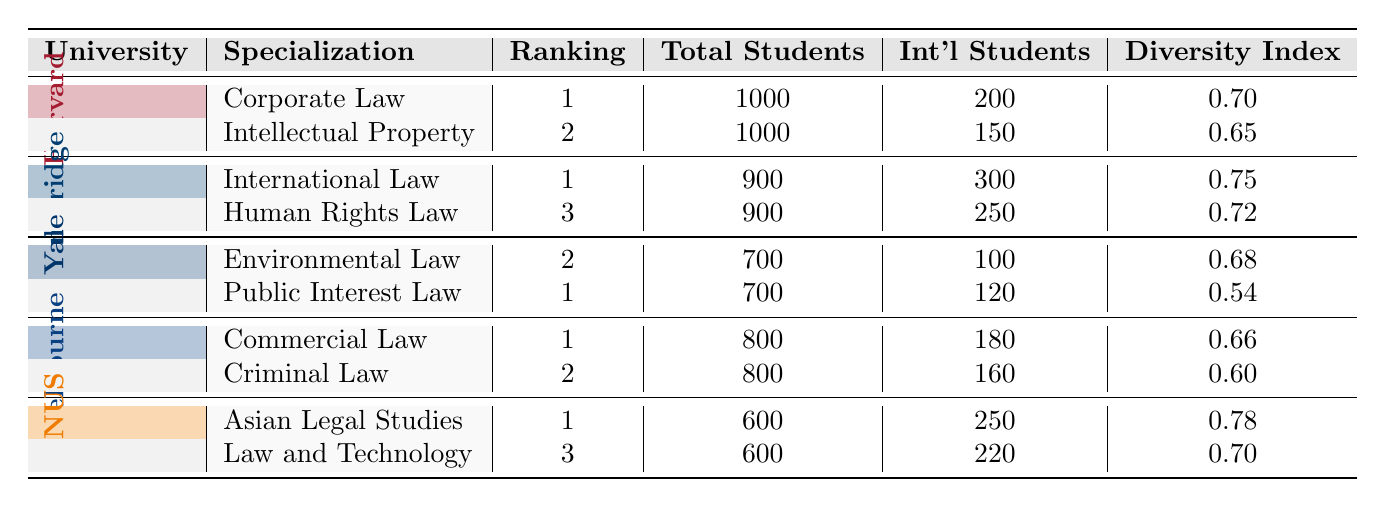What is the total number of international students at Harvard Law School? Harvard Law School has a total of 1000 students, of which 200 are international students as listed under the Corporate Law specialization.
Answer: 200 Which law school has the highest Diversity Index among the listed schools? The National University of Singapore has the highest Diversity Index of 0.78 as per its Asian Legal Studies specialization.
Answer: National University of Singapore What is the sum of total students in the Commercial Law programs of Melbourne and the Environmental Law programs of Yale? The University of Melbourne has 800 total students in Commercial Law and Yale Law School has 700 total students in Environmental Law, so the sum is 800 + 700 = 1500.
Answer: 1500 Is it true that Cambridge has more international students in Human Rights Law than Yale has in Public Interest Law? No, the University of Cambridge has 250 international students in Human Rights Law, while Yale Law School has 120 international students in Public Interest Law, so Cambridge has more.
Answer: No Which specialization at Yale Law School has a better ranking, and how much better is it than the other specialization? Public Interest Law is ranked 1 while Environmental Law is ranked 2. The difference in their rankings is 2 - 1 = 1 ranking position.
Answer: 1 ranking position What percentage of total students are international students in corporate law at Harvard? Harvard Law School has 1000 total students in Corporate Law, and 200 of them are international, so the percentage is (200/1000)*100 = 20%.
Answer: 20% Which university offers a specialization in Law and Technology? The National University of Singapore offers a specialization in Law and Technology.
Answer: National University of Singapore What is the median ranking of all the specializations listed in the table? The rankings are 1, 1, 1, 1, 2, 2, 2, 3, 3. Arranging them gives us: 1, 1, 1, 1, 2, 2, 2, 3, 3. The middle ranking (5th value) is 2.
Answer: 2 What is the ratio of international students to total students in Asian Legal Studies? The National University of Singapore has 600 total students and 250 international students in Asian Legal Studies, so the ratio is 250:600, which simplifies to 5:12.
Answer: 5:12 